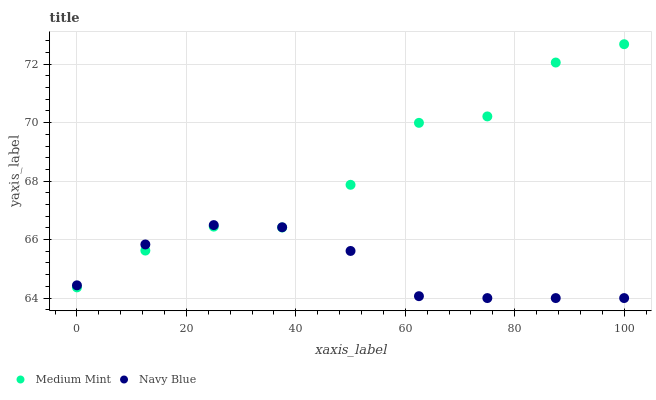Does Navy Blue have the minimum area under the curve?
Answer yes or no. Yes. Does Medium Mint have the maximum area under the curve?
Answer yes or no. Yes. Does Navy Blue have the maximum area under the curve?
Answer yes or no. No. Is Navy Blue the smoothest?
Answer yes or no. Yes. Is Medium Mint the roughest?
Answer yes or no. Yes. Is Navy Blue the roughest?
Answer yes or no. No. Does Navy Blue have the lowest value?
Answer yes or no. Yes. Does Medium Mint have the highest value?
Answer yes or no. Yes. Does Navy Blue have the highest value?
Answer yes or no. No. Does Medium Mint intersect Navy Blue?
Answer yes or no. Yes. Is Medium Mint less than Navy Blue?
Answer yes or no. No. Is Medium Mint greater than Navy Blue?
Answer yes or no. No. 